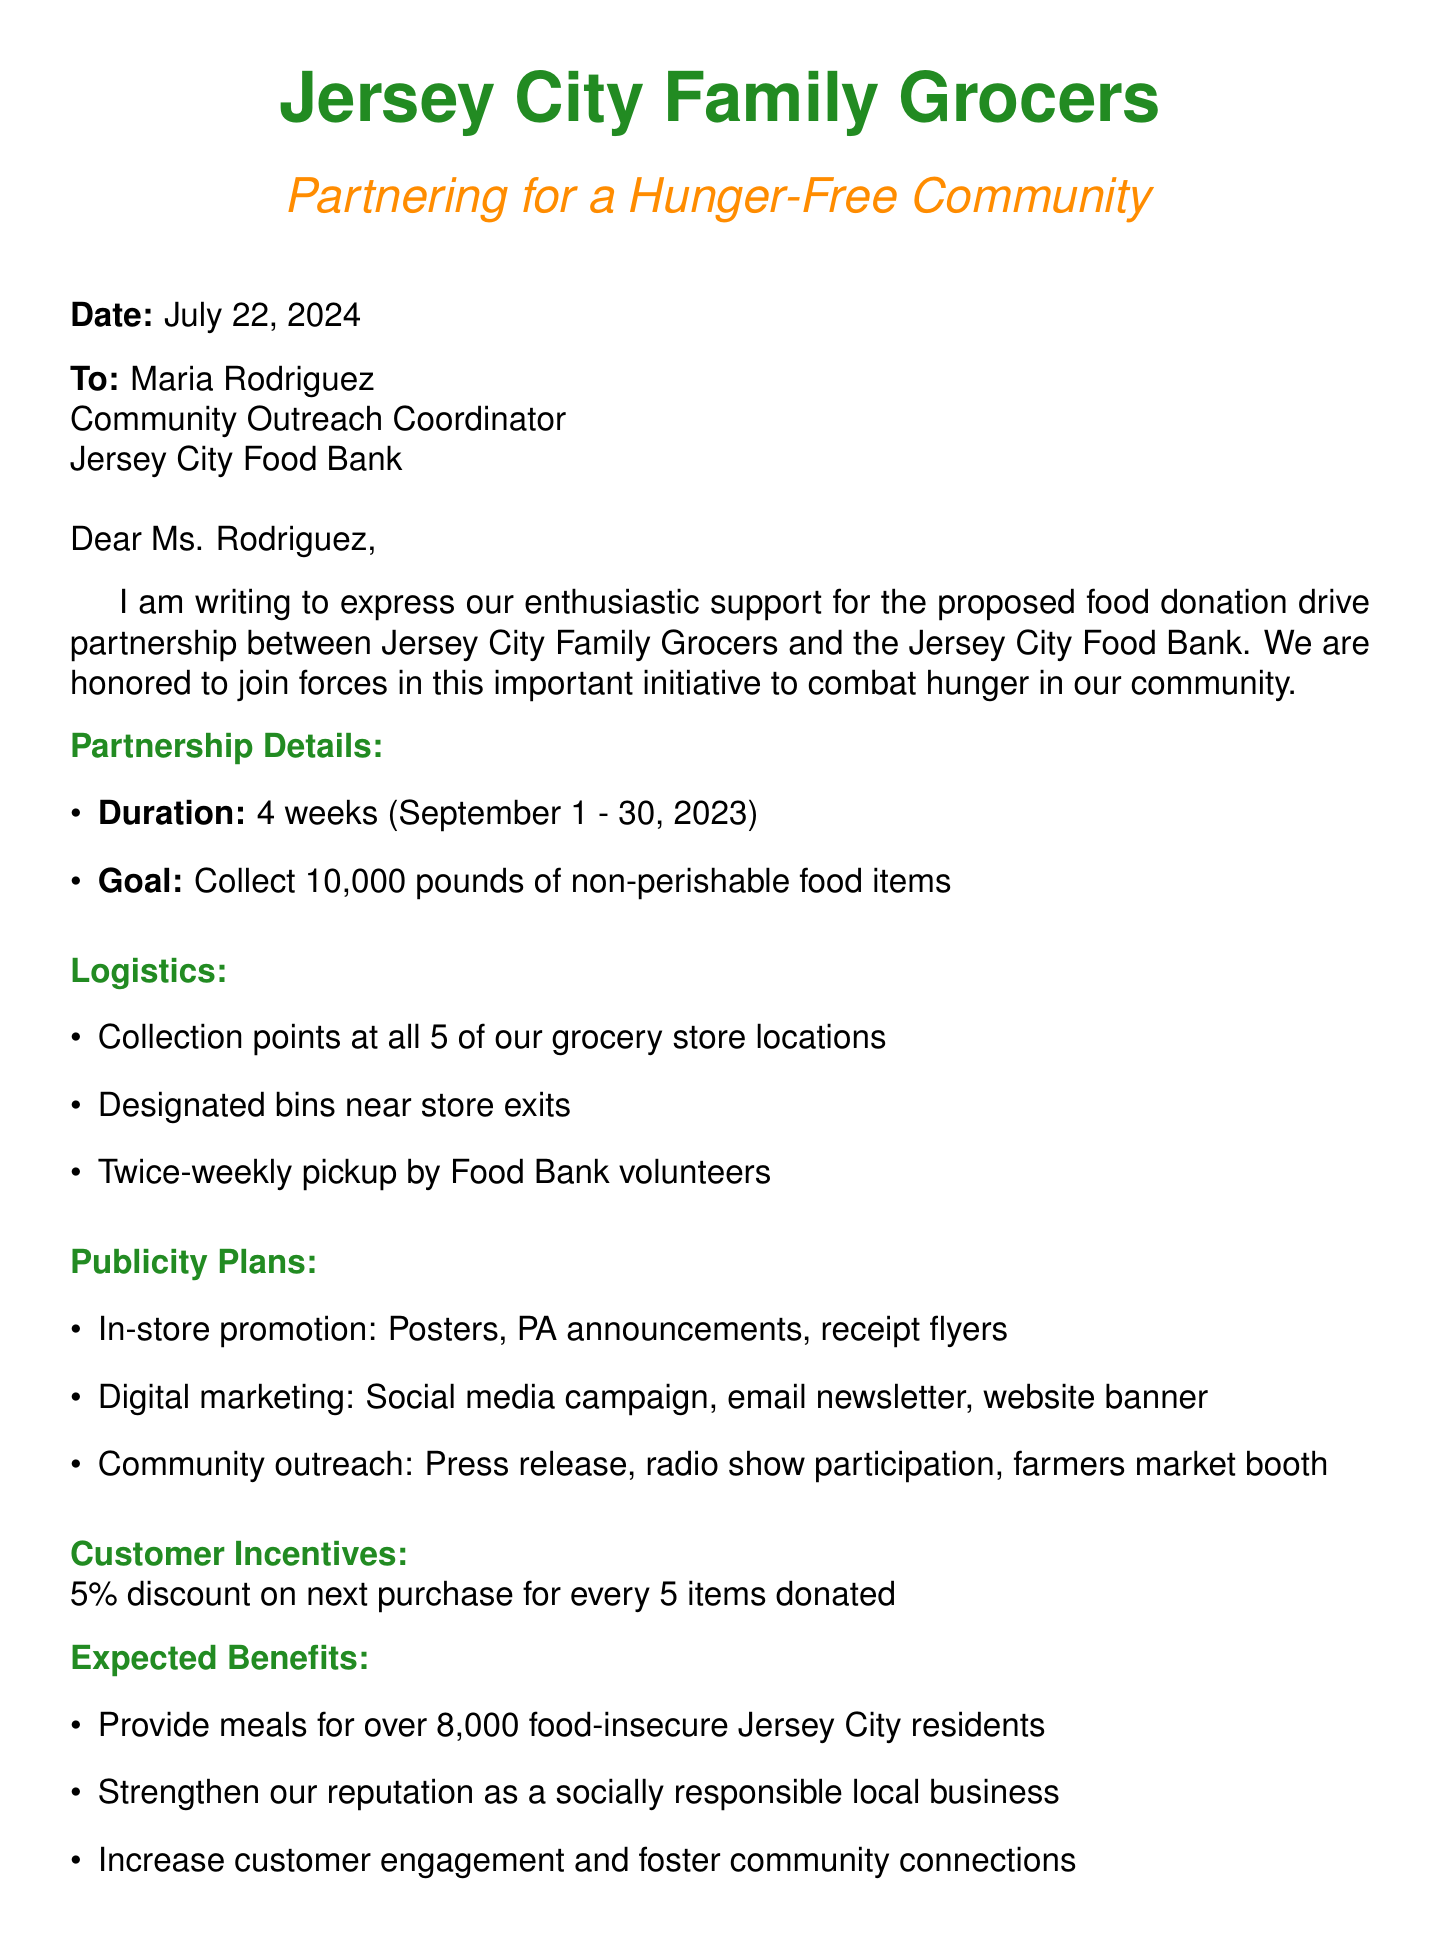What is the name of the charity organization? The charity organization mentioned in the document is the Jersey City Food Bank.
Answer: Jersey City Food Bank Who is the contact person for the partnership? The letter specifies Maria Rodriguez as the contact person for the charity organization.
Answer: Maria Rodriguez What is the total goal for food items to be collected? The document states the goal is to collect 10,000 pounds of non-perishable food items.
Answer: 10,000 pounds When does the food donation drive start? The partnership duration begins on September 1, 2023, according to the document.
Answer: September 1, 2023 What type of items are suggested for donation? The suggested items include canned vegetables and fruits, pasta, rice, peanut butter, jelly, cereal, oatmeal, and canned soups and stews.
Answer: Canned vegetables and fruits What incentive is offered to customers who donate? Customers who donate will receive a 5% discount on their next purchase for every 5 items donated.
Answer: 5% discount How often will pickups be scheduled by Food Bank volunteers? According to the logistics, pickups will be scheduled twice weekly by Food Bank volunteers.
Answer: Twice weekly What is the expected community impact of this partnership? The document highlights that the partnership aims to provide meals for over 8,000 food-insecure Jersey City residents.
Answer: Provide meals for over 8,000 food-insecure residents What type of marketing plan is included for digital outreach? The document mentions a social media campaign on Facebook and Instagram as part of the digital marketing plan.
Answer: Social media campaign What is the format of the letter? This document is structured as a formal letter addressed to a specific individual regarding a partnership proposal.
Answer: Formal letter 